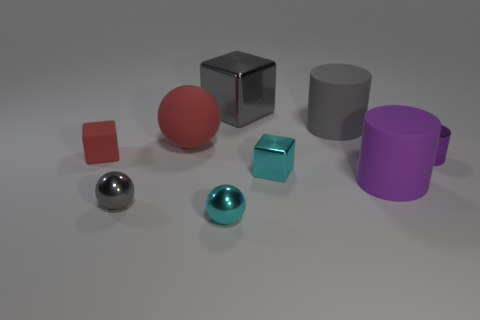Are there any patterns or consistency in the arrangement of these objects? The objects appear to be placed without a specific pattern. They are evenly spaced and seem to be arranged randomly with varying distances between them. The arrangement does not indicate any particular order or sequence in terms of size, shape, color, or finish. 